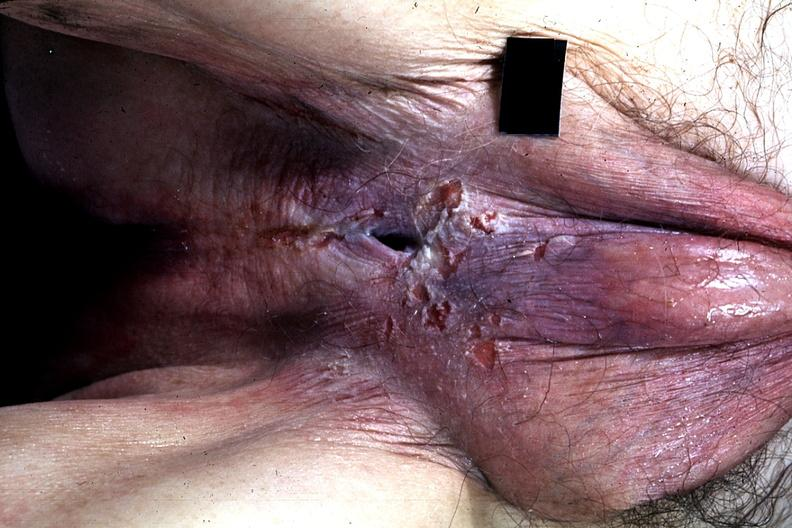s extremities present?
Answer the question using a single word or phrase. No 